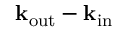Convert formula to latex. <formula><loc_0><loc_0><loc_500><loc_500>k _ { o u t } - k _ { i n }</formula> 